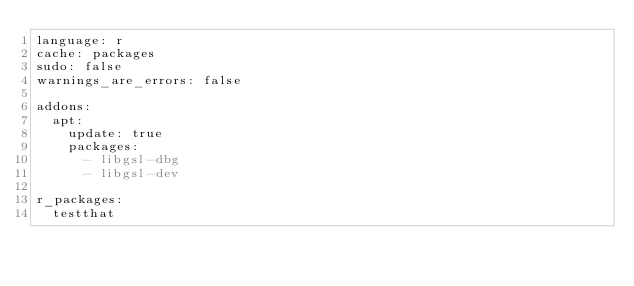<code> <loc_0><loc_0><loc_500><loc_500><_YAML_>language: r
cache: packages
sudo: false
warnings_are_errors: false

addons:
  apt:
    update: true
    packages:
      - libgsl-dbg
      - libgsl-dev

r_packages:
  testthat
</code> 